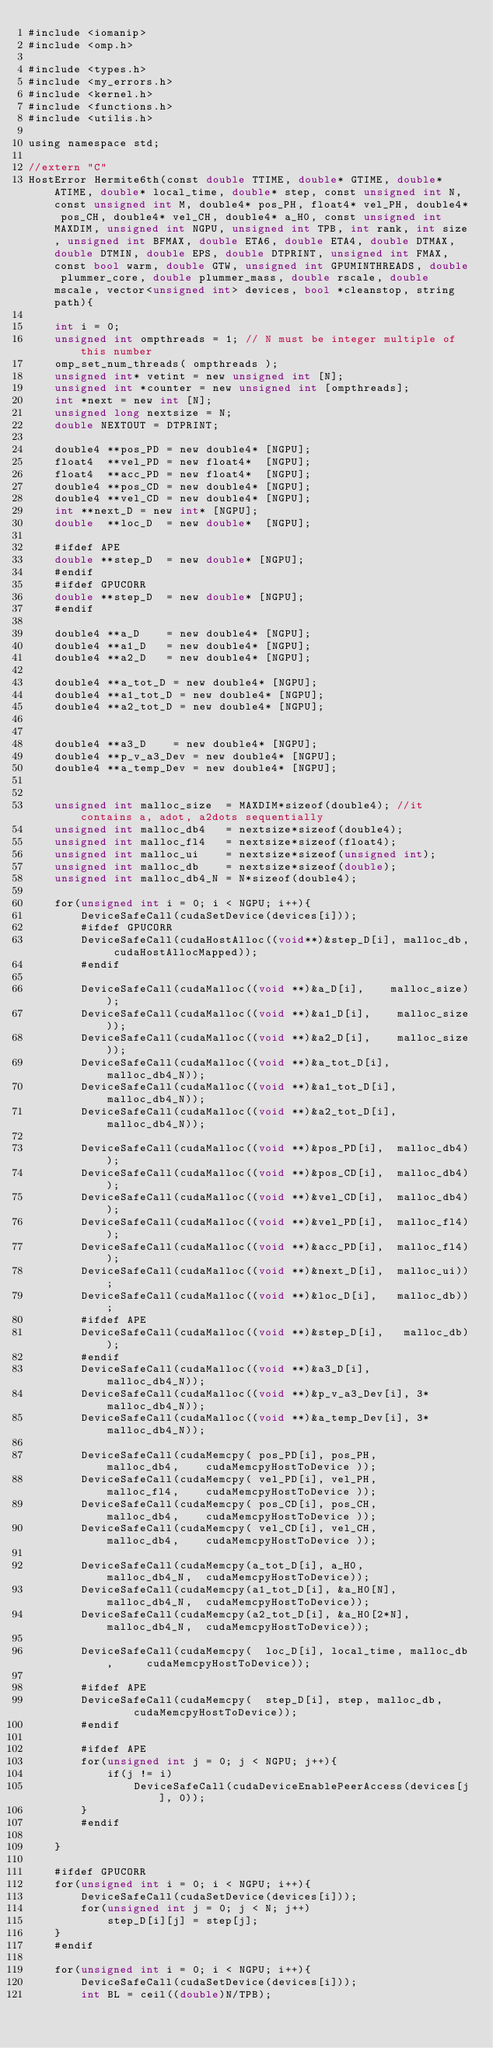Convert code to text. <code><loc_0><loc_0><loc_500><loc_500><_Cuda_>#include <iomanip>
#include <omp.h>

#include <types.h>
#include <my_errors.h>
#include <kernel.h>
#include <functions.h>
#include <utilis.h>

using namespace std;

//extern "C"
HostError Hermite6th(const double TTIME, double* GTIME, double* ATIME, double* local_time, double* step, const unsigned int N, const unsigned int M, double4* pos_PH, float4* vel_PH, double4* pos_CH, double4* vel_CH, double4* a_H0, const unsigned int MAXDIM, unsigned int NGPU, unsigned int TPB, int rank, int size, unsigned int BFMAX, double ETA6, double ETA4, double DTMAX, double DTMIN, double EPS, double DTPRINT, unsigned int FMAX, const bool warm, double GTW, unsigned int GPUMINTHREADS, double plummer_core, double plummer_mass, double rscale, double mscale, vector<unsigned int> devices, bool *cleanstop, string path){

    int i = 0;
    unsigned int ompthreads = 1; // N must be integer multiple of this number
    omp_set_num_threads( ompthreads );
    unsigned int* vetint = new unsigned int [N];
    unsigned int *counter = new unsigned int [ompthreads];
    int *next = new int [N];
    unsigned long nextsize = N;
    double NEXTOUT = DTPRINT;

    double4 **pos_PD = new double4* [NGPU];
    float4  **vel_PD = new float4*  [NGPU];
    float4  **acc_PD = new float4*  [NGPU];
    double4 **pos_CD = new double4* [NGPU];
    double4 **vel_CD = new double4* [NGPU];
    int **next_D = new int* [NGPU];
    double  **loc_D  = new double*  [NGPU];

    #ifdef APE
    double **step_D  = new double* [NGPU];
    #endif
    #ifdef GPUCORR
    double **step_D  = new double* [NGPU];
    #endif

    double4 **a_D    = new double4* [NGPU];
    double4 **a1_D   = new double4* [NGPU];
    double4 **a2_D   = new double4* [NGPU];

    double4 **a_tot_D = new double4* [NGPU];
    double4 **a1_tot_D = new double4* [NGPU];
    double4 **a2_tot_D = new double4* [NGPU];


    double4 **a3_D    = new double4* [NGPU];
    double4 **p_v_a3_Dev = new double4* [NGPU];
    double4 **a_temp_Dev = new double4* [NGPU];


    unsigned int malloc_size  = MAXDIM*sizeof(double4); //it contains a, adot, a2dots sequentially
    unsigned int malloc_db4   = nextsize*sizeof(double4);
    unsigned int malloc_fl4   = nextsize*sizeof(float4);
    unsigned int malloc_ui    = nextsize*sizeof(unsigned int);
    unsigned int malloc_db    = nextsize*sizeof(double);
    unsigned int malloc_db4_N = N*sizeof(double4);

    for(unsigned int i = 0; i < NGPU; i++){
        DeviceSafeCall(cudaSetDevice(devices[i]));
        #ifdef GPUCORR
        DeviceSafeCall(cudaHostAlloc((void**)&step_D[i], malloc_db, cudaHostAllocMapped));
        #endif

        DeviceSafeCall(cudaMalloc((void **)&a_D[i],    malloc_size));
        DeviceSafeCall(cudaMalloc((void **)&a1_D[i],    malloc_size));
        DeviceSafeCall(cudaMalloc((void **)&a2_D[i],    malloc_size));
        DeviceSafeCall(cudaMalloc((void **)&a_tot_D[i], malloc_db4_N));
        DeviceSafeCall(cudaMalloc((void **)&a1_tot_D[i], malloc_db4_N));
        DeviceSafeCall(cudaMalloc((void **)&a2_tot_D[i], malloc_db4_N));

        DeviceSafeCall(cudaMalloc((void **)&pos_PD[i],  malloc_db4));
        DeviceSafeCall(cudaMalloc((void **)&pos_CD[i],  malloc_db4));
        DeviceSafeCall(cudaMalloc((void **)&vel_CD[i],  malloc_db4));
        DeviceSafeCall(cudaMalloc((void **)&vel_PD[i],  malloc_fl4));
        DeviceSafeCall(cudaMalloc((void **)&acc_PD[i],  malloc_fl4));
        DeviceSafeCall(cudaMalloc((void **)&next_D[i],  malloc_ui));
        DeviceSafeCall(cudaMalloc((void **)&loc_D[i],   malloc_db));
        #ifdef APE
        DeviceSafeCall(cudaMalloc((void **)&step_D[i],   malloc_db));
        #endif
        DeviceSafeCall(cudaMalloc((void **)&a3_D[i],    malloc_db4_N));
        DeviceSafeCall(cudaMalloc((void **)&p_v_a3_Dev[i], 3*malloc_db4_N));
        DeviceSafeCall(cudaMalloc((void **)&a_temp_Dev[i], 3*malloc_db4_N));

        DeviceSafeCall(cudaMemcpy( pos_PD[i], pos_PH,     malloc_db4,    cudaMemcpyHostToDevice ));
        DeviceSafeCall(cudaMemcpy( vel_PD[i], vel_PH,     malloc_fl4,    cudaMemcpyHostToDevice ));
        DeviceSafeCall(cudaMemcpy( pos_CD[i], pos_CH,     malloc_db4,    cudaMemcpyHostToDevice ));
        DeviceSafeCall(cudaMemcpy( vel_CD[i], vel_CH,     malloc_db4,    cudaMemcpyHostToDevice ));

        DeviceSafeCall(cudaMemcpy(a_tot_D[i], a_H0,        malloc_db4_N,  cudaMemcpyHostToDevice));
        DeviceSafeCall(cudaMemcpy(a1_tot_D[i], &a_H0[N],   malloc_db4_N,  cudaMemcpyHostToDevice));
        DeviceSafeCall(cudaMemcpy(a2_tot_D[i], &a_H0[2*N], malloc_db4_N,  cudaMemcpyHostToDevice));

        DeviceSafeCall(cudaMemcpy(  loc_D[i], local_time, malloc_db,     cudaMemcpyHostToDevice));

        #ifdef APE
        DeviceSafeCall(cudaMemcpy(  step_D[i], step, malloc_db,     cudaMemcpyHostToDevice));
        #endif

        #ifdef APE
        for(unsigned int j = 0; j < NGPU; j++){
            if(j != i)
                DeviceSafeCall(cudaDeviceEnablePeerAccess(devices[j], 0));
        }
        #endif

    }

    #ifdef GPUCORR
    for(unsigned int i = 0; i < NGPU; i++){
        DeviceSafeCall(cudaSetDevice(devices[i]));
        for(unsigned int j = 0; j < N; j++)
            step_D[i][j] = step[j];
    }
    #endif

    for(unsigned int i = 0; i < NGPU; i++){
        DeviceSafeCall(cudaSetDevice(devices[i]));
        int BL = ceil((double)N/TPB);</code> 